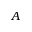Convert formula to latex. <formula><loc_0><loc_0><loc_500><loc_500>A</formula> 